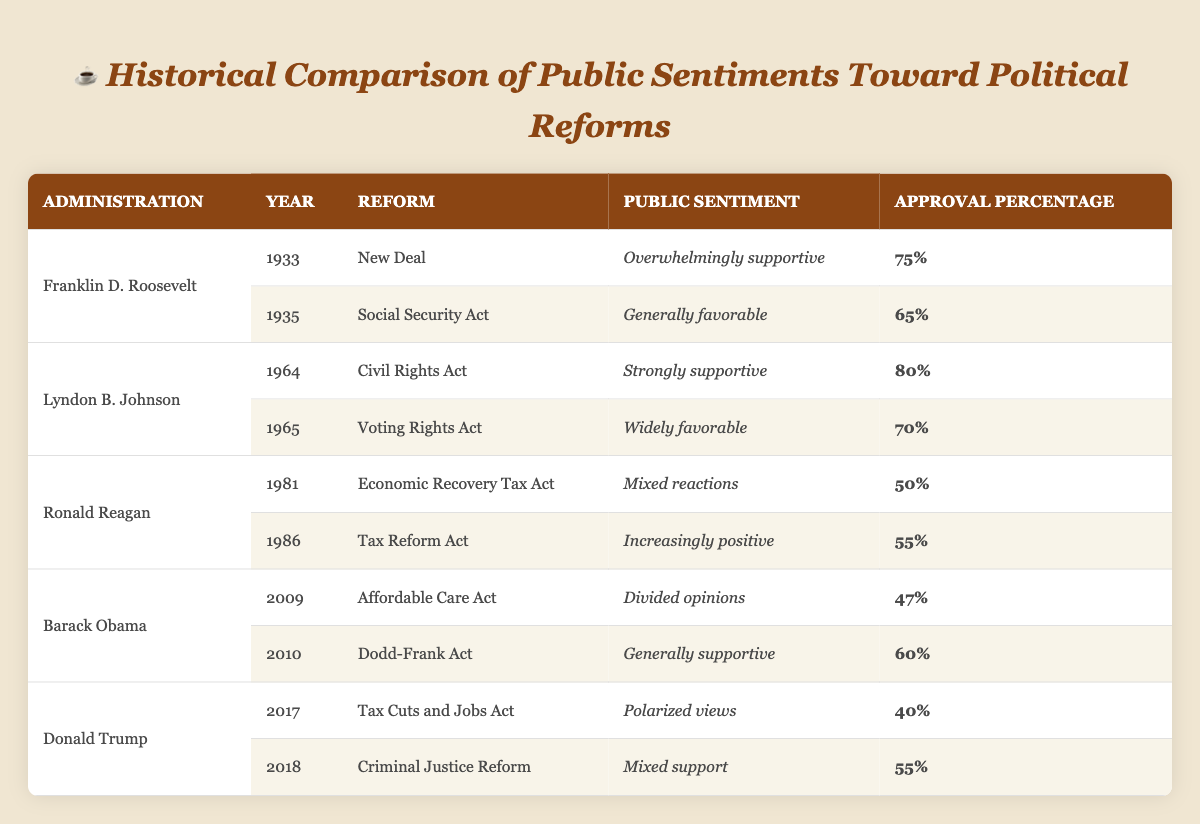What was the public sentiment toward the Affordable Care Act in 2009? The table indicates that the public sentiment toward the Affordable Care Act in 2009 was described as "divided opinions," and the approval percentage was 47%.
Answer: Divided opinions Which political figure had the highest approval percentage for reforms listed? The highest approval percentage is found under Lyndon B. Johnson, with the Civil Rights Act in 1964, which has a percentage of 80%.
Answer: Lyndon B. Johnson What is the average approval percentage for Ronald Reagan's reforms? The approval percentages for Ronald Reagan's reforms (50% for Economic Recovery Tax Act and 55% for Tax Reform Act) are averaged as follows: (50 + 55) / 2 = 105 / 2 = 52.5%.
Answer: 52.5% Did Franklin D. Roosevelt have any reform with a public sentiment categorized as "mixed reactions"? The table shows that all reforms attributed to Franklin D. Roosevelt have sentiments that are either overwhelmingly supportive or generally favorable, thus confirming he had no reform with mixed reactions.
Answer: No How did the sentiments toward Barack Obama's reforms compare to those of Donald Trump? Barack Obama's reforms displayed divided opinions (47% for the Affordable Care Act) and generally supportive (60% for the Dodd-Frank Act), while Donald Trump's reforms reflected polarized views (40% for the Tax Cuts and Jobs Act) and mixed support (55% for Criminal Justice Reform). This comparison shows that Obama’s sentiments were more supportive overall than Trump's, which were largely polarized.
Answer: Obama's sentiments were more supportive than Trump's 